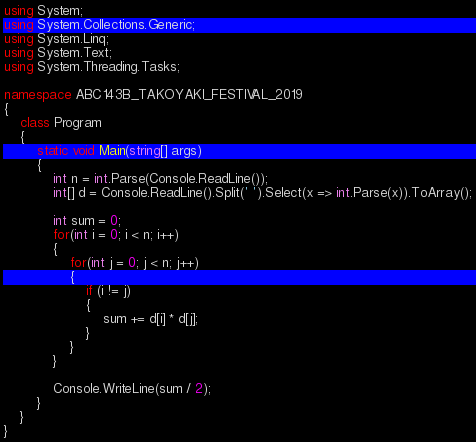Convert code to text. <code><loc_0><loc_0><loc_500><loc_500><_C#_>using System;
using System.Collections.Generic;
using System.Linq;
using System.Text;
using System.Threading.Tasks;

namespace ABC143B_TAKOYAKI_FESTIVAL_2019
{
    class Program
    {
        static void Main(string[] args)
        {
            int n = int.Parse(Console.ReadLine());
            int[] d = Console.ReadLine().Split(' ').Select(x => int.Parse(x)).ToArray();

            int sum = 0;
            for(int i = 0; i < n; i++)
            {
                for(int j = 0; j < n; j++)
                {
                    if (i != j)
                    {
                        sum += d[i] * d[j];
                    }
                }
            }

            Console.WriteLine(sum / 2);
        }
    }
}
</code> 